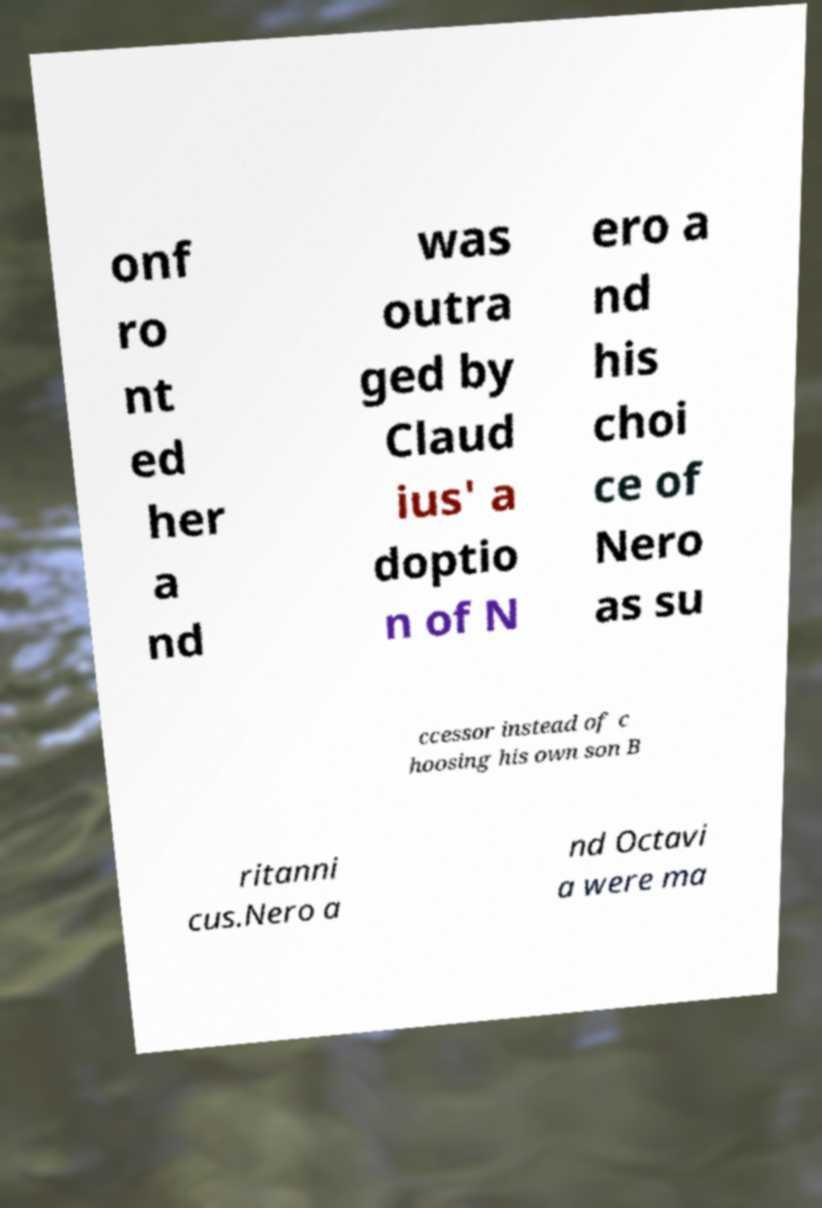I need the written content from this picture converted into text. Can you do that? onf ro nt ed her a nd was outra ged by Claud ius' a doptio n of N ero a nd his choi ce of Nero as su ccessor instead of c hoosing his own son B ritanni cus.Nero a nd Octavi a were ma 